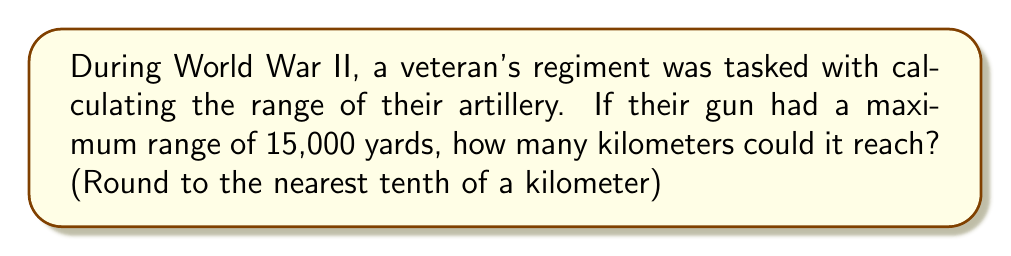Provide a solution to this math problem. To solve this problem, we need to convert yards to kilometers. Let's break it down step-by-step:

1. First, recall the conversion factor:
   1 yard ≈ 0.9144 meters

2. We need to convert 15,000 yards to meters:
   $15,000 \text{ yards} \times 0.9144 \text{ meters/yard} = 13,716 \text{ meters}$

3. Now, we need to convert meters to kilometers:
   $13,716 \text{ meters} \times \frac{1 \text{ kilometer}}{1000 \text{ meters}} = 13.716 \text{ kilometers}$

4. Rounding to the nearest tenth of a kilometer:
   $13.716 \text{ kilometers} \approx 13.7 \text{ kilometers}$

Therefore, the artillery gun with a maximum range of 15,000 yards could reach approximately 13.7 kilometers.
Answer: 13.7 km 